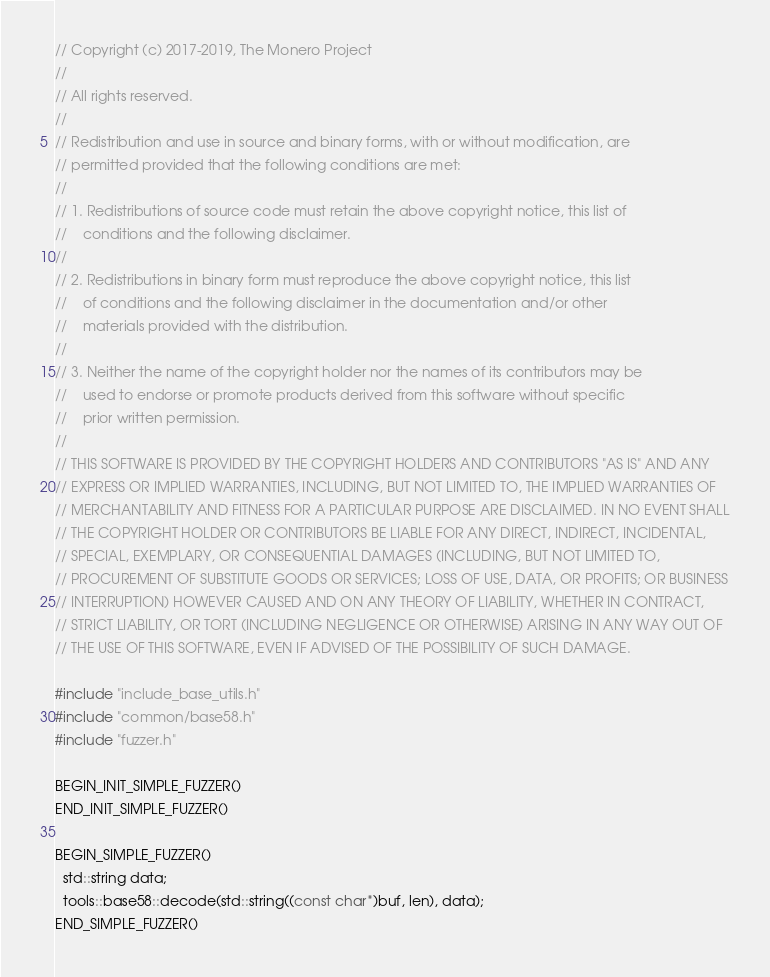Convert code to text. <code><loc_0><loc_0><loc_500><loc_500><_C++_>// Copyright (c) 2017-2019, The Monero Project
// 
// All rights reserved.
// 
// Redistribution and use in source and binary forms, with or without modification, are
// permitted provided that the following conditions are met:
// 
// 1. Redistributions of source code must retain the above copyright notice, this list of
//    conditions and the following disclaimer.
// 
// 2. Redistributions in binary form must reproduce the above copyright notice, this list
//    of conditions and the following disclaimer in the documentation and/or other
//    materials provided with the distribution.
// 
// 3. Neither the name of the copyright holder nor the names of its contributors may be
//    used to endorse or promote products derived from this software without specific
//    prior written permission.
// 
// THIS SOFTWARE IS PROVIDED BY THE COPYRIGHT HOLDERS AND CONTRIBUTORS "AS IS" AND ANY
// EXPRESS OR IMPLIED WARRANTIES, INCLUDING, BUT NOT LIMITED TO, THE IMPLIED WARRANTIES OF
// MERCHANTABILITY AND FITNESS FOR A PARTICULAR PURPOSE ARE DISCLAIMED. IN NO EVENT SHALL
// THE COPYRIGHT HOLDER OR CONTRIBUTORS BE LIABLE FOR ANY DIRECT, INDIRECT, INCIDENTAL,
// SPECIAL, EXEMPLARY, OR CONSEQUENTIAL DAMAGES (INCLUDING, BUT NOT LIMITED TO,
// PROCUREMENT OF SUBSTITUTE GOODS OR SERVICES; LOSS OF USE, DATA, OR PROFITS; OR BUSINESS
// INTERRUPTION) HOWEVER CAUSED AND ON ANY THEORY OF LIABILITY, WHETHER IN CONTRACT,
// STRICT LIABILITY, OR TORT (INCLUDING NEGLIGENCE OR OTHERWISE) ARISING IN ANY WAY OUT OF
// THE USE OF THIS SOFTWARE, EVEN IF ADVISED OF THE POSSIBILITY OF SUCH DAMAGE.

#include "include_base_utils.h"
#include "common/base58.h"
#include "fuzzer.h"

BEGIN_INIT_SIMPLE_FUZZER()
END_INIT_SIMPLE_FUZZER()

BEGIN_SIMPLE_FUZZER()
  std::string data;
  tools::base58::decode(std::string((const char*)buf, len), data);
END_SIMPLE_FUZZER()
</code> 